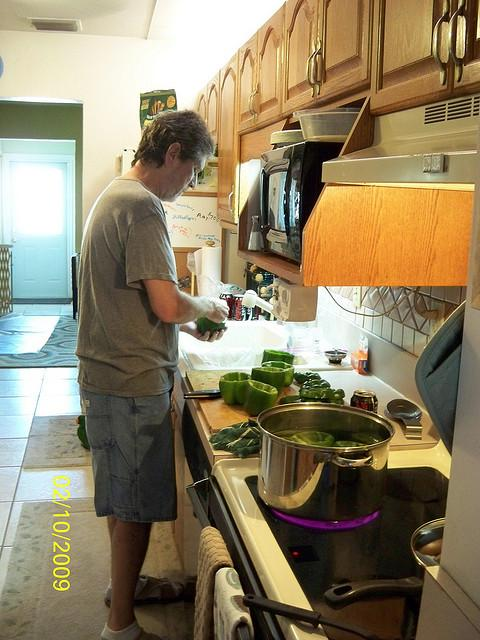What is the person cooking on the stove?

Choices:
A) artichokes
B) corn
C) green peppers
D) asparagus green peppers 